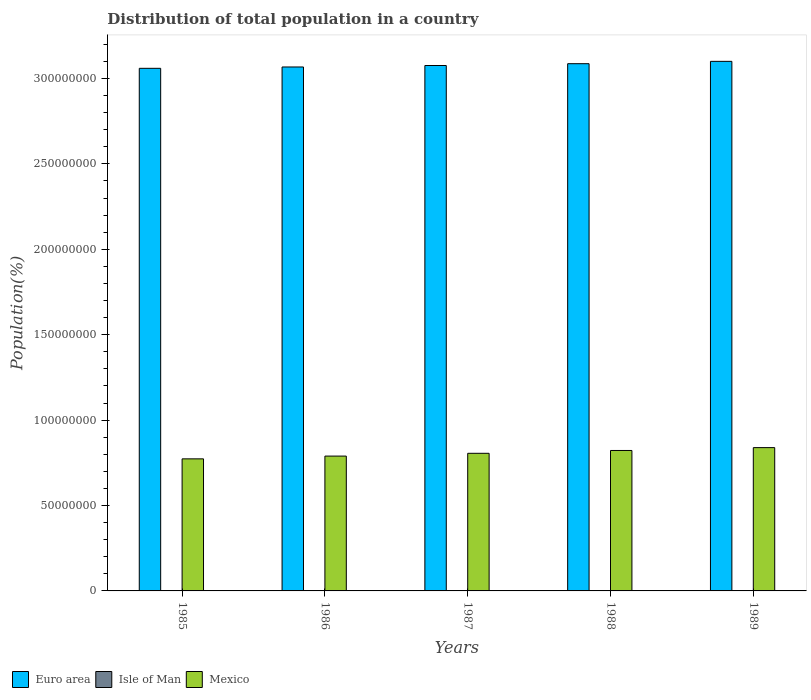How many different coloured bars are there?
Your response must be concise. 3. How many groups of bars are there?
Your answer should be compact. 5. Are the number of bars per tick equal to the number of legend labels?
Offer a very short reply. Yes. Are the number of bars on each tick of the X-axis equal?
Provide a short and direct response. Yes. What is the population of in Mexico in 1986?
Give a very brief answer. 7.89e+07. Across all years, what is the maximum population of in Mexico?
Your answer should be compact. 8.39e+07. Across all years, what is the minimum population of in Isle of Man?
Provide a succinct answer. 6.44e+04. What is the total population of in Mexico in the graph?
Give a very brief answer. 4.03e+08. What is the difference between the population of in Isle of Man in 1988 and that in 1989?
Provide a succinct answer. -1363. What is the difference between the population of in Euro area in 1988 and the population of in Isle of Man in 1985?
Your answer should be very brief. 3.09e+08. What is the average population of in Mexico per year?
Your response must be concise. 8.06e+07. In the year 1987, what is the difference between the population of in Euro area and population of in Isle of Man?
Ensure brevity in your answer.  3.08e+08. What is the ratio of the population of in Euro area in 1986 to that in 1989?
Provide a short and direct response. 0.99. What is the difference between the highest and the second highest population of in Mexico?
Your answer should be very brief. 1.68e+06. What is the difference between the highest and the lowest population of in Mexico?
Your answer should be compact. 6.58e+06. In how many years, is the population of in Mexico greater than the average population of in Mexico taken over all years?
Your response must be concise. 2. Is it the case that in every year, the sum of the population of in Isle of Man and population of in Mexico is greater than the population of in Euro area?
Provide a succinct answer. No. Are all the bars in the graph horizontal?
Ensure brevity in your answer.  No. Does the graph contain any zero values?
Offer a very short reply. No. Does the graph contain grids?
Ensure brevity in your answer.  No. Where does the legend appear in the graph?
Provide a short and direct response. Bottom left. How many legend labels are there?
Make the answer very short. 3. What is the title of the graph?
Your response must be concise. Distribution of total population in a country. Does "Papua New Guinea" appear as one of the legend labels in the graph?
Offer a terse response. No. What is the label or title of the Y-axis?
Your response must be concise. Population(%). What is the Population(%) of Euro area in 1985?
Provide a short and direct response. 3.06e+08. What is the Population(%) of Isle of Man in 1985?
Make the answer very short. 6.44e+04. What is the Population(%) of Mexico in 1985?
Provide a succinct answer. 7.73e+07. What is the Population(%) in Euro area in 1986?
Your answer should be compact. 3.07e+08. What is the Population(%) of Isle of Man in 1986?
Your response must be concise. 6.52e+04. What is the Population(%) in Mexico in 1986?
Give a very brief answer. 7.89e+07. What is the Population(%) of Euro area in 1987?
Provide a short and direct response. 3.08e+08. What is the Population(%) of Isle of Man in 1987?
Make the answer very short. 6.64e+04. What is the Population(%) in Mexico in 1987?
Offer a terse response. 8.06e+07. What is the Population(%) of Euro area in 1988?
Offer a terse response. 3.09e+08. What is the Population(%) of Isle of Man in 1988?
Give a very brief answer. 6.79e+04. What is the Population(%) in Mexico in 1988?
Provide a succinct answer. 8.22e+07. What is the Population(%) in Euro area in 1989?
Provide a succinct answer. 3.10e+08. What is the Population(%) of Isle of Man in 1989?
Offer a very short reply. 6.93e+04. What is the Population(%) of Mexico in 1989?
Your response must be concise. 8.39e+07. Across all years, what is the maximum Population(%) of Euro area?
Offer a very short reply. 3.10e+08. Across all years, what is the maximum Population(%) of Isle of Man?
Keep it short and to the point. 6.93e+04. Across all years, what is the maximum Population(%) in Mexico?
Provide a short and direct response. 8.39e+07. Across all years, what is the minimum Population(%) of Euro area?
Offer a terse response. 3.06e+08. Across all years, what is the minimum Population(%) in Isle of Man?
Offer a very short reply. 6.44e+04. Across all years, what is the minimum Population(%) of Mexico?
Provide a succinct answer. 7.73e+07. What is the total Population(%) in Euro area in the graph?
Your answer should be very brief. 1.54e+09. What is the total Population(%) of Isle of Man in the graph?
Your answer should be very brief. 3.33e+05. What is the total Population(%) in Mexico in the graph?
Offer a very short reply. 4.03e+08. What is the difference between the Population(%) of Euro area in 1985 and that in 1986?
Offer a very short reply. -7.80e+05. What is the difference between the Population(%) in Isle of Man in 1985 and that in 1986?
Give a very brief answer. -779. What is the difference between the Population(%) in Mexico in 1985 and that in 1986?
Provide a succinct answer. -1.62e+06. What is the difference between the Population(%) of Euro area in 1985 and that in 1987?
Offer a terse response. -1.65e+06. What is the difference between the Population(%) of Isle of Man in 1985 and that in 1987?
Keep it short and to the point. -2003. What is the difference between the Population(%) in Mexico in 1985 and that in 1987?
Your response must be concise. -3.25e+06. What is the difference between the Population(%) of Euro area in 1985 and that in 1988?
Provide a succinct answer. -2.71e+06. What is the difference between the Population(%) of Isle of Man in 1985 and that in 1988?
Your answer should be compact. -3456. What is the difference between the Population(%) of Mexico in 1985 and that in 1988?
Your answer should be compact. -4.90e+06. What is the difference between the Population(%) of Euro area in 1985 and that in 1989?
Offer a very short reply. -4.08e+06. What is the difference between the Population(%) of Isle of Man in 1985 and that in 1989?
Offer a very short reply. -4819. What is the difference between the Population(%) of Mexico in 1985 and that in 1989?
Your response must be concise. -6.58e+06. What is the difference between the Population(%) in Euro area in 1986 and that in 1987?
Offer a terse response. -8.66e+05. What is the difference between the Population(%) of Isle of Man in 1986 and that in 1987?
Keep it short and to the point. -1224. What is the difference between the Population(%) of Mexico in 1986 and that in 1987?
Your answer should be very brief. -1.63e+06. What is the difference between the Population(%) in Euro area in 1986 and that in 1988?
Provide a short and direct response. -1.93e+06. What is the difference between the Population(%) of Isle of Man in 1986 and that in 1988?
Your answer should be compact. -2677. What is the difference between the Population(%) of Mexico in 1986 and that in 1988?
Keep it short and to the point. -3.28e+06. What is the difference between the Population(%) of Euro area in 1986 and that in 1989?
Make the answer very short. -3.30e+06. What is the difference between the Population(%) of Isle of Man in 1986 and that in 1989?
Keep it short and to the point. -4040. What is the difference between the Population(%) in Mexico in 1986 and that in 1989?
Provide a short and direct response. -4.96e+06. What is the difference between the Population(%) of Euro area in 1987 and that in 1988?
Your answer should be very brief. -1.06e+06. What is the difference between the Population(%) of Isle of Man in 1987 and that in 1988?
Your answer should be very brief. -1453. What is the difference between the Population(%) in Mexico in 1987 and that in 1988?
Offer a terse response. -1.65e+06. What is the difference between the Population(%) of Euro area in 1987 and that in 1989?
Ensure brevity in your answer.  -2.43e+06. What is the difference between the Population(%) of Isle of Man in 1987 and that in 1989?
Your answer should be compact. -2816. What is the difference between the Population(%) of Mexico in 1987 and that in 1989?
Keep it short and to the point. -3.33e+06. What is the difference between the Population(%) in Euro area in 1988 and that in 1989?
Ensure brevity in your answer.  -1.37e+06. What is the difference between the Population(%) of Isle of Man in 1988 and that in 1989?
Ensure brevity in your answer.  -1363. What is the difference between the Population(%) of Mexico in 1988 and that in 1989?
Your answer should be very brief. -1.68e+06. What is the difference between the Population(%) of Euro area in 1985 and the Population(%) of Isle of Man in 1986?
Ensure brevity in your answer.  3.06e+08. What is the difference between the Population(%) of Euro area in 1985 and the Population(%) of Mexico in 1986?
Make the answer very short. 2.27e+08. What is the difference between the Population(%) of Isle of Man in 1985 and the Population(%) of Mexico in 1986?
Provide a short and direct response. -7.89e+07. What is the difference between the Population(%) of Euro area in 1985 and the Population(%) of Isle of Man in 1987?
Offer a very short reply. 3.06e+08. What is the difference between the Population(%) in Euro area in 1985 and the Population(%) in Mexico in 1987?
Give a very brief answer. 2.25e+08. What is the difference between the Population(%) in Isle of Man in 1985 and the Population(%) in Mexico in 1987?
Provide a succinct answer. -8.05e+07. What is the difference between the Population(%) of Euro area in 1985 and the Population(%) of Isle of Man in 1988?
Your response must be concise. 3.06e+08. What is the difference between the Population(%) in Euro area in 1985 and the Population(%) in Mexico in 1988?
Make the answer very short. 2.24e+08. What is the difference between the Population(%) in Isle of Man in 1985 and the Population(%) in Mexico in 1988?
Offer a terse response. -8.22e+07. What is the difference between the Population(%) of Euro area in 1985 and the Population(%) of Isle of Man in 1989?
Give a very brief answer. 3.06e+08. What is the difference between the Population(%) in Euro area in 1985 and the Population(%) in Mexico in 1989?
Provide a succinct answer. 2.22e+08. What is the difference between the Population(%) in Isle of Man in 1985 and the Population(%) in Mexico in 1989?
Ensure brevity in your answer.  -8.38e+07. What is the difference between the Population(%) of Euro area in 1986 and the Population(%) of Isle of Man in 1987?
Ensure brevity in your answer.  3.07e+08. What is the difference between the Population(%) of Euro area in 1986 and the Population(%) of Mexico in 1987?
Provide a succinct answer. 2.26e+08. What is the difference between the Population(%) in Isle of Man in 1986 and the Population(%) in Mexico in 1987?
Give a very brief answer. -8.05e+07. What is the difference between the Population(%) in Euro area in 1986 and the Population(%) in Isle of Man in 1988?
Give a very brief answer. 3.07e+08. What is the difference between the Population(%) of Euro area in 1986 and the Population(%) of Mexico in 1988?
Ensure brevity in your answer.  2.25e+08. What is the difference between the Population(%) of Isle of Man in 1986 and the Population(%) of Mexico in 1988?
Offer a terse response. -8.22e+07. What is the difference between the Population(%) of Euro area in 1986 and the Population(%) of Isle of Man in 1989?
Your answer should be very brief. 3.07e+08. What is the difference between the Population(%) of Euro area in 1986 and the Population(%) of Mexico in 1989?
Give a very brief answer. 2.23e+08. What is the difference between the Population(%) of Isle of Man in 1986 and the Population(%) of Mexico in 1989?
Provide a short and direct response. -8.38e+07. What is the difference between the Population(%) in Euro area in 1987 and the Population(%) in Isle of Man in 1988?
Provide a short and direct response. 3.08e+08. What is the difference between the Population(%) in Euro area in 1987 and the Population(%) in Mexico in 1988?
Your response must be concise. 2.25e+08. What is the difference between the Population(%) of Isle of Man in 1987 and the Population(%) of Mexico in 1988?
Your answer should be compact. -8.22e+07. What is the difference between the Population(%) in Euro area in 1987 and the Population(%) in Isle of Man in 1989?
Provide a succinct answer. 3.08e+08. What is the difference between the Population(%) of Euro area in 1987 and the Population(%) of Mexico in 1989?
Offer a terse response. 2.24e+08. What is the difference between the Population(%) of Isle of Man in 1987 and the Population(%) of Mexico in 1989?
Keep it short and to the point. -8.38e+07. What is the difference between the Population(%) of Euro area in 1988 and the Population(%) of Isle of Man in 1989?
Make the answer very short. 3.09e+08. What is the difference between the Population(%) in Euro area in 1988 and the Population(%) in Mexico in 1989?
Offer a very short reply. 2.25e+08. What is the difference between the Population(%) of Isle of Man in 1988 and the Population(%) of Mexico in 1989?
Make the answer very short. -8.38e+07. What is the average Population(%) of Euro area per year?
Give a very brief answer. 3.08e+08. What is the average Population(%) in Isle of Man per year?
Provide a succinct answer. 6.67e+04. What is the average Population(%) in Mexico per year?
Give a very brief answer. 8.06e+07. In the year 1985, what is the difference between the Population(%) in Euro area and Population(%) in Isle of Man?
Offer a very short reply. 3.06e+08. In the year 1985, what is the difference between the Population(%) in Euro area and Population(%) in Mexico?
Keep it short and to the point. 2.29e+08. In the year 1985, what is the difference between the Population(%) in Isle of Man and Population(%) in Mexico?
Provide a succinct answer. -7.73e+07. In the year 1986, what is the difference between the Population(%) in Euro area and Population(%) in Isle of Man?
Give a very brief answer. 3.07e+08. In the year 1986, what is the difference between the Population(%) of Euro area and Population(%) of Mexico?
Make the answer very short. 2.28e+08. In the year 1986, what is the difference between the Population(%) of Isle of Man and Population(%) of Mexico?
Offer a terse response. -7.89e+07. In the year 1987, what is the difference between the Population(%) of Euro area and Population(%) of Isle of Man?
Offer a terse response. 3.08e+08. In the year 1987, what is the difference between the Population(%) of Euro area and Population(%) of Mexico?
Provide a short and direct response. 2.27e+08. In the year 1987, what is the difference between the Population(%) of Isle of Man and Population(%) of Mexico?
Provide a short and direct response. -8.05e+07. In the year 1988, what is the difference between the Population(%) of Euro area and Population(%) of Isle of Man?
Your answer should be very brief. 3.09e+08. In the year 1988, what is the difference between the Population(%) of Euro area and Population(%) of Mexico?
Ensure brevity in your answer.  2.26e+08. In the year 1988, what is the difference between the Population(%) of Isle of Man and Population(%) of Mexico?
Your answer should be compact. -8.22e+07. In the year 1989, what is the difference between the Population(%) in Euro area and Population(%) in Isle of Man?
Provide a succinct answer. 3.10e+08. In the year 1989, what is the difference between the Population(%) in Euro area and Population(%) in Mexico?
Provide a succinct answer. 2.26e+08. In the year 1989, what is the difference between the Population(%) in Isle of Man and Population(%) in Mexico?
Your answer should be very brief. -8.38e+07. What is the ratio of the Population(%) of Euro area in 1985 to that in 1986?
Offer a very short reply. 1. What is the ratio of the Population(%) in Mexico in 1985 to that in 1986?
Provide a succinct answer. 0.98. What is the ratio of the Population(%) of Euro area in 1985 to that in 1987?
Your answer should be compact. 0.99. What is the ratio of the Population(%) of Isle of Man in 1985 to that in 1987?
Your answer should be very brief. 0.97. What is the ratio of the Population(%) in Mexico in 1985 to that in 1987?
Your response must be concise. 0.96. What is the ratio of the Population(%) of Isle of Man in 1985 to that in 1988?
Ensure brevity in your answer.  0.95. What is the ratio of the Population(%) in Mexico in 1985 to that in 1988?
Your response must be concise. 0.94. What is the ratio of the Population(%) of Euro area in 1985 to that in 1989?
Your answer should be compact. 0.99. What is the ratio of the Population(%) in Isle of Man in 1985 to that in 1989?
Offer a terse response. 0.93. What is the ratio of the Population(%) of Mexico in 1985 to that in 1989?
Give a very brief answer. 0.92. What is the ratio of the Population(%) in Isle of Man in 1986 to that in 1987?
Offer a very short reply. 0.98. What is the ratio of the Population(%) in Mexico in 1986 to that in 1987?
Your response must be concise. 0.98. What is the ratio of the Population(%) of Isle of Man in 1986 to that in 1988?
Ensure brevity in your answer.  0.96. What is the ratio of the Population(%) in Mexico in 1986 to that in 1988?
Your answer should be very brief. 0.96. What is the ratio of the Population(%) in Isle of Man in 1986 to that in 1989?
Make the answer very short. 0.94. What is the ratio of the Population(%) of Mexico in 1986 to that in 1989?
Ensure brevity in your answer.  0.94. What is the ratio of the Population(%) in Isle of Man in 1987 to that in 1988?
Give a very brief answer. 0.98. What is the ratio of the Population(%) in Mexico in 1987 to that in 1988?
Ensure brevity in your answer.  0.98. What is the ratio of the Population(%) in Isle of Man in 1987 to that in 1989?
Offer a terse response. 0.96. What is the ratio of the Population(%) in Mexico in 1987 to that in 1989?
Provide a succinct answer. 0.96. What is the ratio of the Population(%) of Euro area in 1988 to that in 1989?
Your answer should be very brief. 1. What is the ratio of the Population(%) in Isle of Man in 1988 to that in 1989?
Give a very brief answer. 0.98. What is the ratio of the Population(%) of Mexico in 1988 to that in 1989?
Offer a very short reply. 0.98. What is the difference between the highest and the second highest Population(%) of Euro area?
Give a very brief answer. 1.37e+06. What is the difference between the highest and the second highest Population(%) of Isle of Man?
Provide a short and direct response. 1363. What is the difference between the highest and the second highest Population(%) of Mexico?
Keep it short and to the point. 1.68e+06. What is the difference between the highest and the lowest Population(%) of Euro area?
Provide a short and direct response. 4.08e+06. What is the difference between the highest and the lowest Population(%) in Isle of Man?
Ensure brevity in your answer.  4819. What is the difference between the highest and the lowest Population(%) of Mexico?
Give a very brief answer. 6.58e+06. 